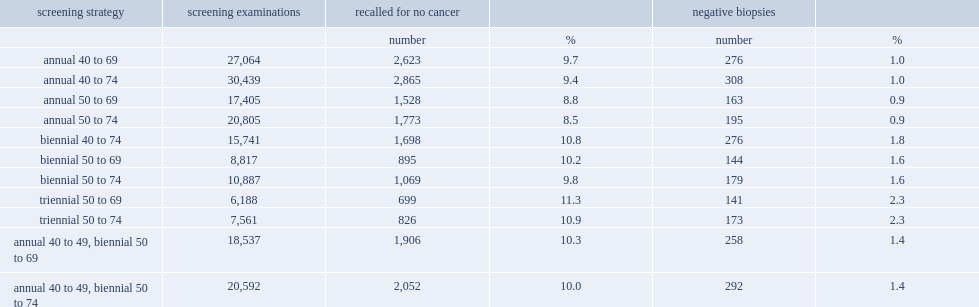What was the per 1,000 numbers for biennial screening at ages 50 to 69? 144.0. What was the per 1,000 numbers for triennial screening at ages 50 to 69? 141.0. What was the per 1,000 numbers for annual screening at ages 40 to 74? 308.0. 